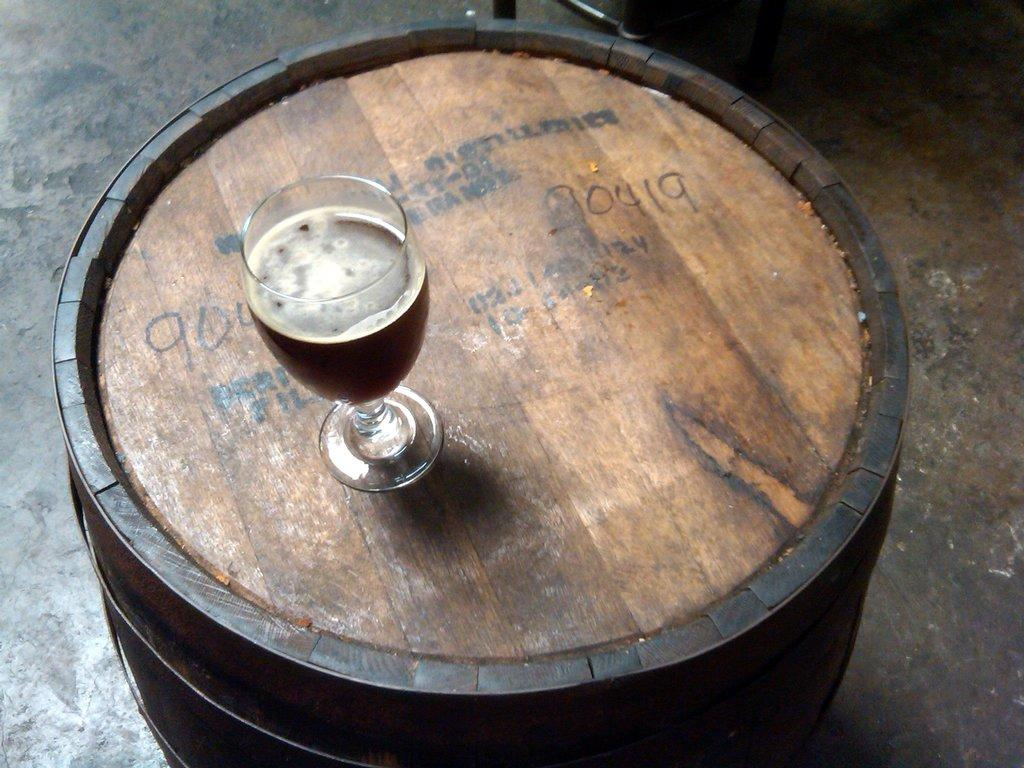What type of table is in the foreground of the image? There is a circular table in the foreground of the image. What object is placed on the table? A glass is placed on the table. Can you describe the setting of the image? The image is likely taken in a hall. What part of the room can be seen in the background of the image? The floor is visible in the background of the image. What type of punishment is being administered to the rat in the image? There is no rat present in the image, and therefore no punishment is being administered. 